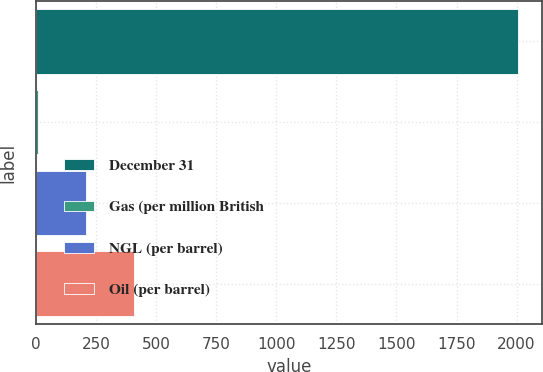Convert chart. <chart><loc_0><loc_0><loc_500><loc_500><bar_chart><fcel>December 31<fcel>Gas (per million British<fcel>NGL (per barrel)<fcel>Oil (per barrel)<nl><fcel>2007<fcel>6.8<fcel>206.82<fcel>406.84<nl></chart> 